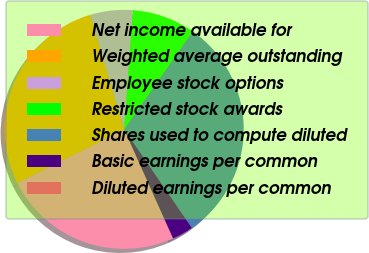Convert chart. <chart><loc_0><loc_0><loc_500><loc_500><pie_chart><fcel>Net income available for<fcel>Weighted average outstanding<fcel>Employee stock options<fcel>Restricted stock awards<fcel>Shares used to compute diluted<fcel>Basic earnings per common<fcel>Diluted earnings per common<nl><fcel>24.31%<fcel>27.84%<fcel>5.72%<fcel>8.57%<fcel>30.7%<fcel>2.86%<fcel>0.0%<nl></chart> 